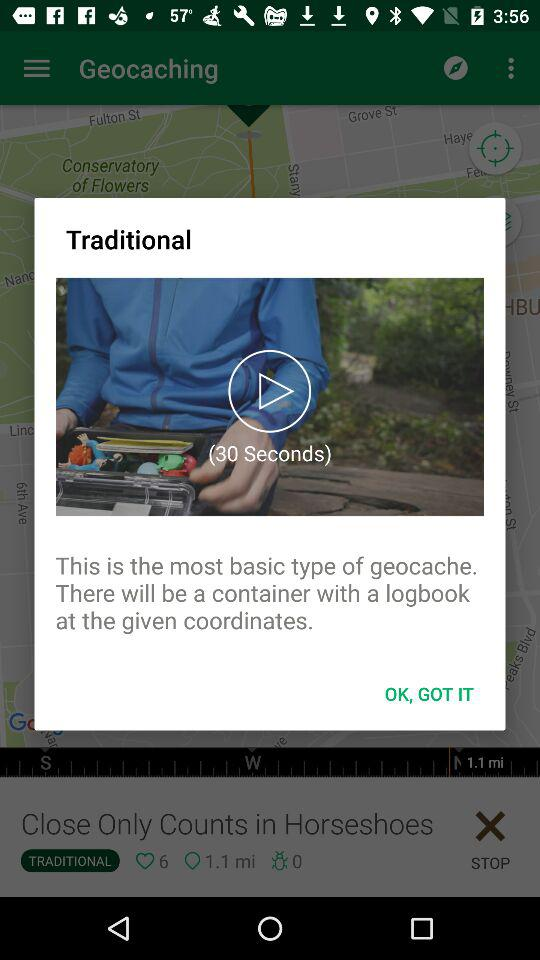What is the video length? The video length is 30 seconds. 